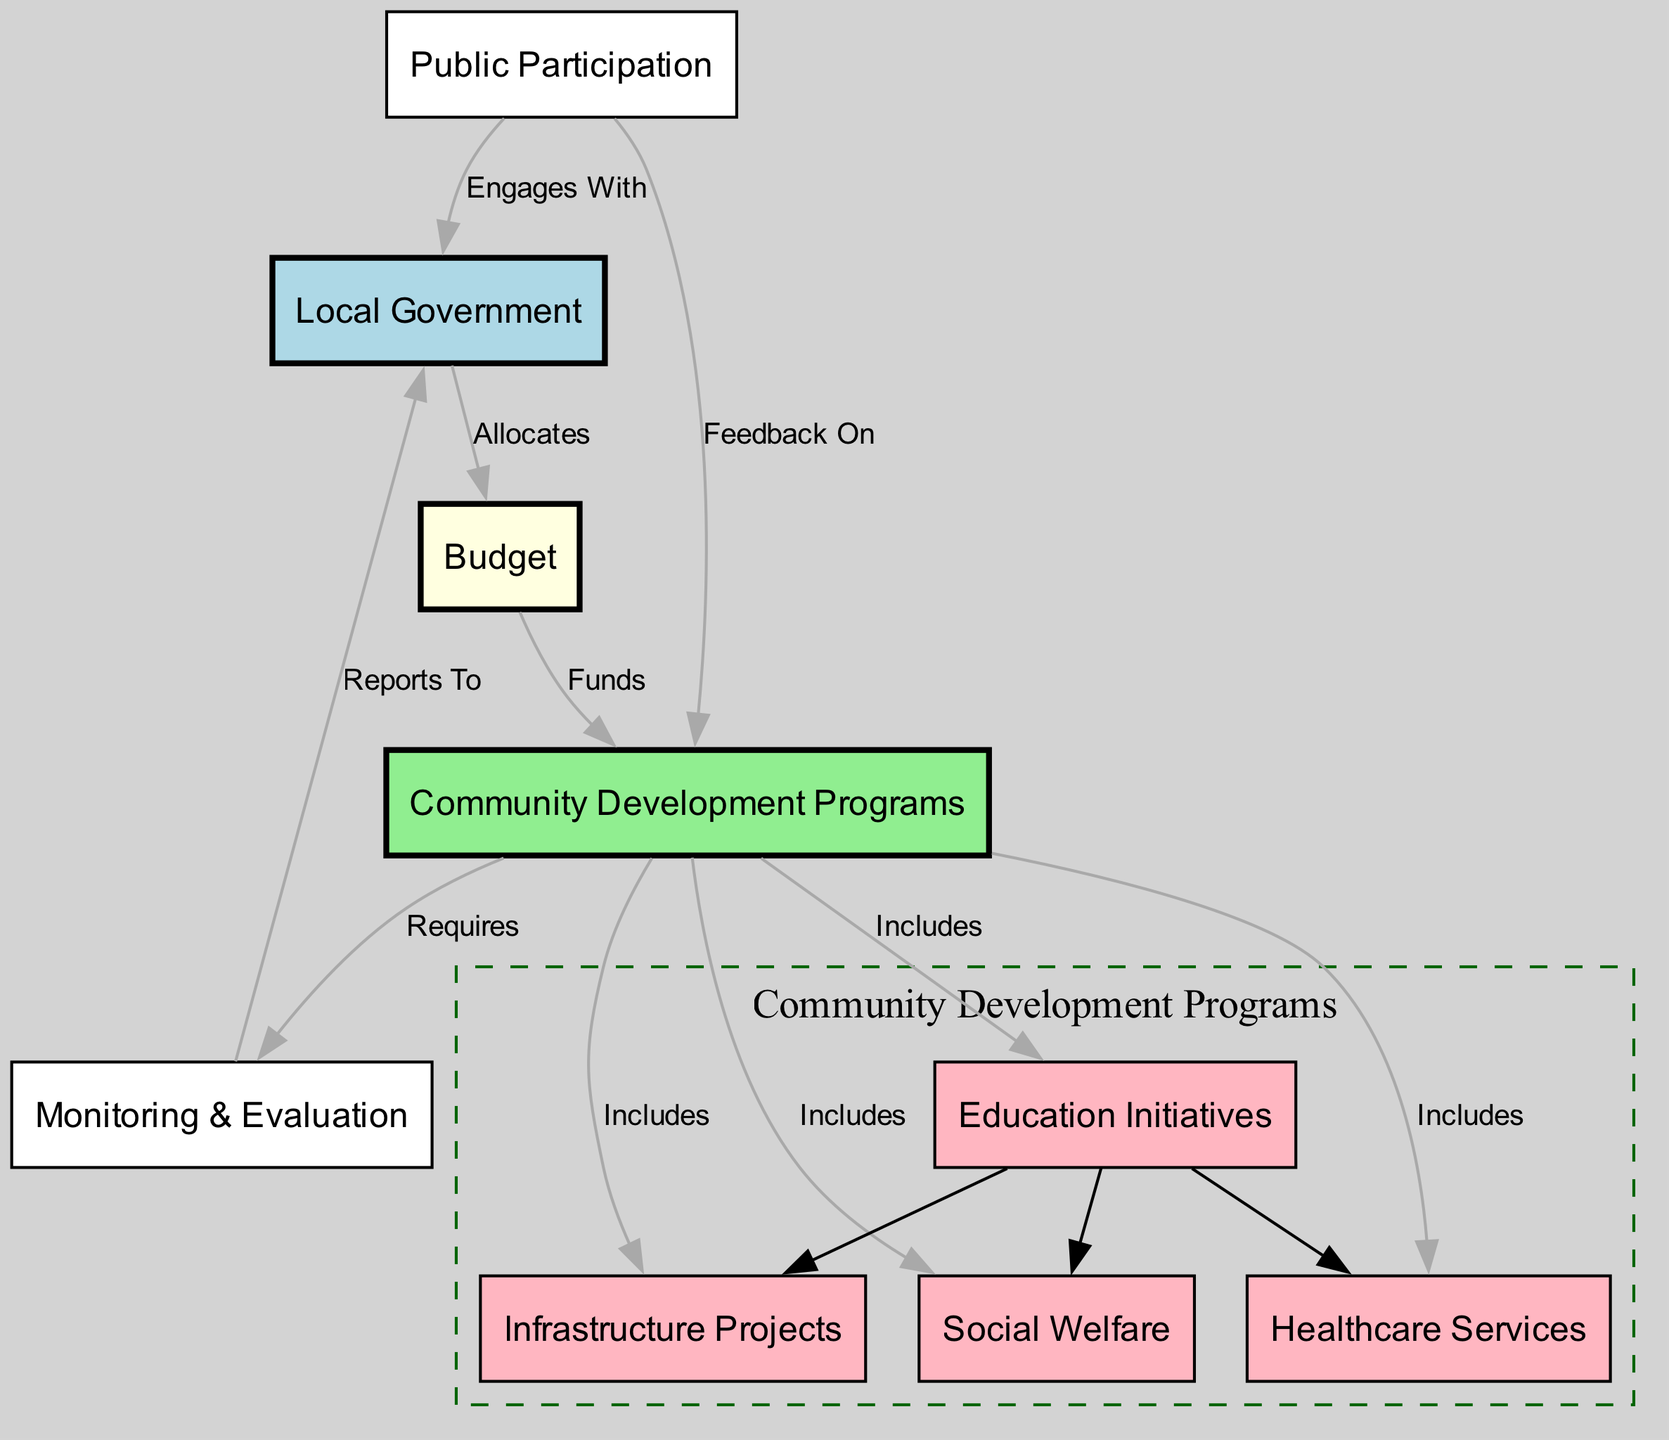What is the main entity depicted in the diagram? The diagram primarily represents "Local Government" as the central entity, which is the starting point for resource allocation and budget distribution.
Answer: Local Government How many nodes are present in the diagram? By counting the unique entities depicted in the diagram, we find there are 9 nodes indicating different components involved in resource allocation and budget distribution.
Answer: 9 What does the Local Government allocate? The Local Government allocates the "Budget" which serves as the funding source for various community development programs.
Answer: Budget Which programs are included under Community Development Programs? The Community Development Programs include "Education Initiatives," "Healthcare Services," "Infrastructure Projects," and "Social Welfare," as indicated by the connections linking these programs to the main node.
Answer: Education Initiatives, Healthcare Services, Infrastructure Projects, Social Welfare How does Public Participation interact with the Local Government? Public Participation is indicated to "Engage With" the Local Government, showing the relationship between citizen involvement and governmental functions.
Answer: Engages With Which component requires Monitoring & Evaluation? The "Community Development Programs" requires the "Monitoring & Evaluation" component, suggesting that oversight and assessment are crucial for the effectiveness of these programs.
Answer: Monitoring & Evaluation What is the relationship between Monitoring & Evaluation and Local Government? Monitoring & Evaluation "Reports To" the Local Government, indicating that the evaluation outcomes are communicated back to the governing body for further action or adjustment.
Answer: Reports To How do Community Development Programs engage with Public Participation? Community Development Programs have a feedback mechanism where Public Participation provides "Feedback On" these programs, showing a two-way interaction between the community and government initiatives.
Answer: Feedback On What color represents the Budget in the diagram? The Budget node is represented in "light yellow," distinguishing it from other components and indicating its significance in the allocation process.
Answer: light yellow 